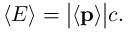<formula> <loc_0><loc_0><loc_500><loc_500>\langle E \rangle = { \left | } \langle p \rangle { \right | } c .</formula> 